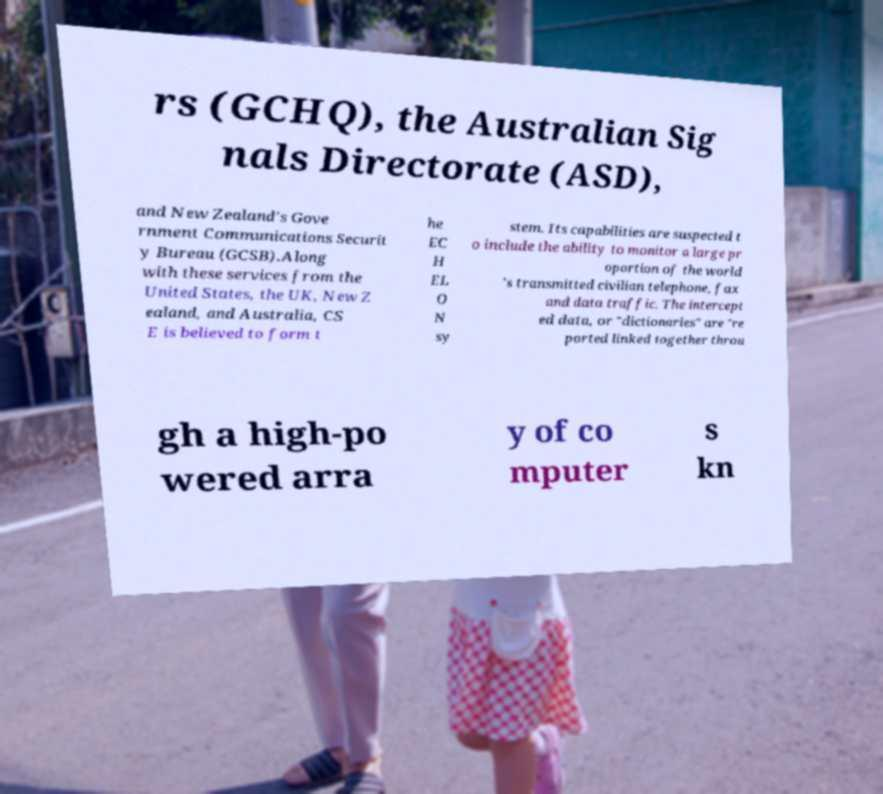Please identify and transcribe the text found in this image. rs (GCHQ), the Australian Sig nals Directorate (ASD), and New Zealand's Gove rnment Communications Securit y Bureau (GCSB).Along with these services from the United States, the UK, New Z ealand, and Australia, CS E is believed to form t he EC H EL O N sy stem. Its capabilities are suspected t o include the ability to monitor a large pr oportion of the world 's transmitted civilian telephone, fax and data traffic. The intercept ed data, or "dictionaries" are "re ported linked together throu gh a high-po wered arra y of co mputer s kn 